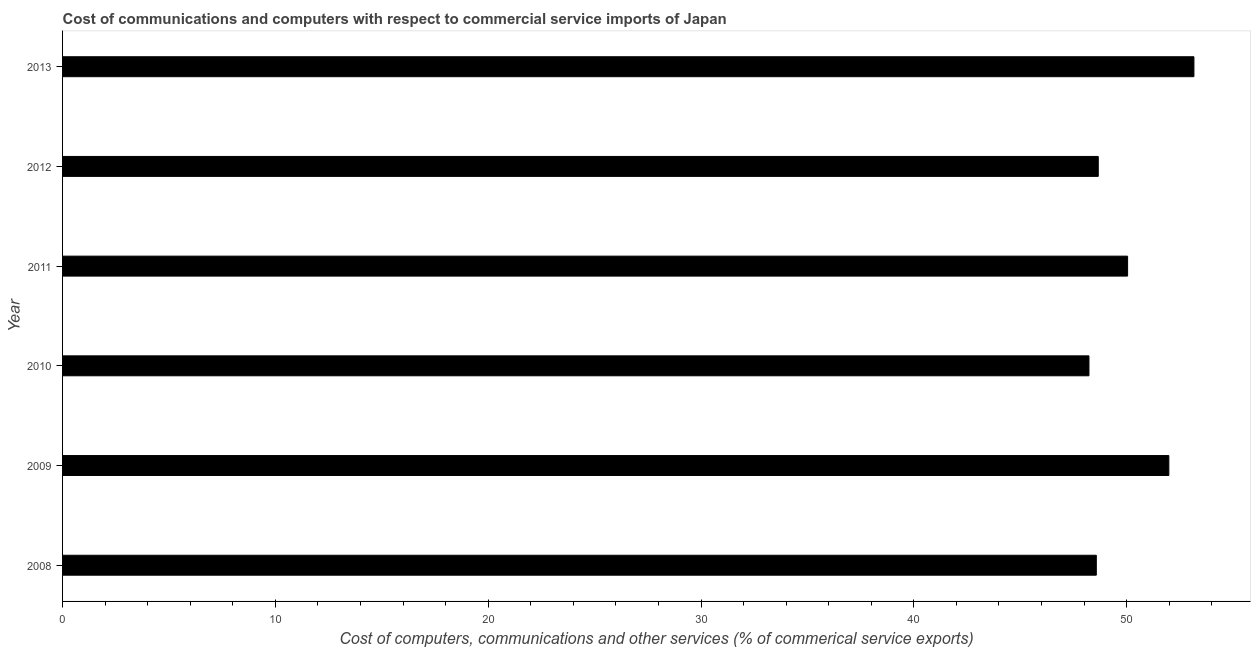What is the title of the graph?
Provide a succinct answer. Cost of communications and computers with respect to commercial service imports of Japan. What is the label or title of the X-axis?
Make the answer very short. Cost of computers, communications and other services (% of commerical service exports). What is the  computer and other services in 2009?
Your answer should be compact. 51.98. Across all years, what is the maximum  computer and other services?
Your answer should be very brief. 53.16. Across all years, what is the minimum cost of communications?
Ensure brevity in your answer.  48.23. What is the sum of the cost of communications?
Give a very brief answer. 300.65. What is the difference between the  computer and other services in 2008 and 2011?
Make the answer very short. -1.47. What is the average cost of communications per year?
Your answer should be very brief. 50.11. What is the median  computer and other services?
Offer a terse response. 49.35. Do a majority of the years between 2008 and 2011 (inclusive) have cost of communications greater than 50 %?
Keep it short and to the point. No. What is the ratio of the  computer and other services in 2008 to that in 2011?
Your response must be concise. 0.97. What is the difference between the highest and the second highest cost of communications?
Provide a succinct answer. 1.18. What is the difference between the highest and the lowest cost of communications?
Provide a short and direct response. 4.93. How many years are there in the graph?
Your response must be concise. 6. What is the difference between two consecutive major ticks on the X-axis?
Ensure brevity in your answer.  10. Are the values on the major ticks of X-axis written in scientific E-notation?
Your answer should be compact. No. What is the Cost of computers, communications and other services (% of commerical service exports) in 2008?
Offer a terse response. 48.57. What is the Cost of computers, communications and other services (% of commerical service exports) of 2009?
Ensure brevity in your answer.  51.98. What is the Cost of computers, communications and other services (% of commerical service exports) of 2010?
Provide a succinct answer. 48.23. What is the Cost of computers, communications and other services (% of commerical service exports) in 2011?
Give a very brief answer. 50.04. What is the Cost of computers, communications and other services (% of commerical service exports) of 2012?
Ensure brevity in your answer.  48.66. What is the Cost of computers, communications and other services (% of commerical service exports) in 2013?
Provide a succinct answer. 53.16. What is the difference between the Cost of computers, communications and other services (% of commerical service exports) in 2008 and 2009?
Keep it short and to the point. -3.41. What is the difference between the Cost of computers, communications and other services (% of commerical service exports) in 2008 and 2010?
Your answer should be compact. 0.35. What is the difference between the Cost of computers, communications and other services (% of commerical service exports) in 2008 and 2011?
Give a very brief answer. -1.47. What is the difference between the Cost of computers, communications and other services (% of commerical service exports) in 2008 and 2012?
Your response must be concise. -0.09. What is the difference between the Cost of computers, communications and other services (% of commerical service exports) in 2008 and 2013?
Your response must be concise. -4.59. What is the difference between the Cost of computers, communications and other services (% of commerical service exports) in 2009 and 2010?
Offer a very short reply. 3.75. What is the difference between the Cost of computers, communications and other services (% of commerical service exports) in 2009 and 2011?
Your response must be concise. 1.94. What is the difference between the Cost of computers, communications and other services (% of commerical service exports) in 2009 and 2012?
Make the answer very short. 3.32. What is the difference between the Cost of computers, communications and other services (% of commerical service exports) in 2009 and 2013?
Your response must be concise. -1.18. What is the difference between the Cost of computers, communications and other services (% of commerical service exports) in 2010 and 2011?
Ensure brevity in your answer.  -1.82. What is the difference between the Cost of computers, communications and other services (% of commerical service exports) in 2010 and 2012?
Offer a terse response. -0.44. What is the difference between the Cost of computers, communications and other services (% of commerical service exports) in 2010 and 2013?
Offer a terse response. -4.93. What is the difference between the Cost of computers, communications and other services (% of commerical service exports) in 2011 and 2012?
Your response must be concise. 1.38. What is the difference between the Cost of computers, communications and other services (% of commerical service exports) in 2011 and 2013?
Your answer should be very brief. -3.12. What is the difference between the Cost of computers, communications and other services (% of commerical service exports) in 2012 and 2013?
Offer a terse response. -4.5. What is the ratio of the Cost of computers, communications and other services (% of commerical service exports) in 2008 to that in 2009?
Offer a very short reply. 0.93. What is the ratio of the Cost of computers, communications and other services (% of commerical service exports) in 2008 to that in 2012?
Ensure brevity in your answer.  1. What is the ratio of the Cost of computers, communications and other services (% of commerical service exports) in 2008 to that in 2013?
Your answer should be compact. 0.91. What is the ratio of the Cost of computers, communications and other services (% of commerical service exports) in 2009 to that in 2010?
Your answer should be very brief. 1.08. What is the ratio of the Cost of computers, communications and other services (% of commerical service exports) in 2009 to that in 2011?
Ensure brevity in your answer.  1.04. What is the ratio of the Cost of computers, communications and other services (% of commerical service exports) in 2009 to that in 2012?
Keep it short and to the point. 1.07. What is the ratio of the Cost of computers, communications and other services (% of commerical service exports) in 2010 to that in 2013?
Keep it short and to the point. 0.91. What is the ratio of the Cost of computers, communications and other services (% of commerical service exports) in 2011 to that in 2012?
Offer a terse response. 1.03. What is the ratio of the Cost of computers, communications and other services (% of commerical service exports) in 2011 to that in 2013?
Offer a terse response. 0.94. What is the ratio of the Cost of computers, communications and other services (% of commerical service exports) in 2012 to that in 2013?
Provide a short and direct response. 0.92. 